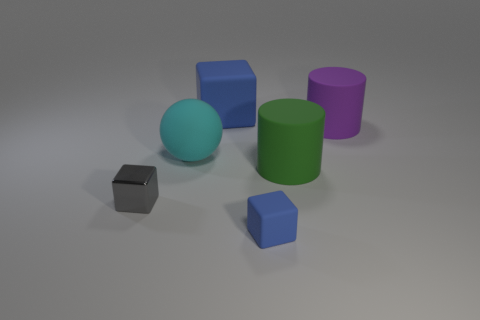Add 1 large cylinders. How many objects exist? 7 Subtract all spheres. How many objects are left? 5 Add 6 large rubber balls. How many large rubber balls are left? 7 Add 3 cyan balls. How many cyan balls exist? 4 Subtract 0 green balls. How many objects are left? 6 Subtract all matte cylinders. Subtract all large spheres. How many objects are left? 3 